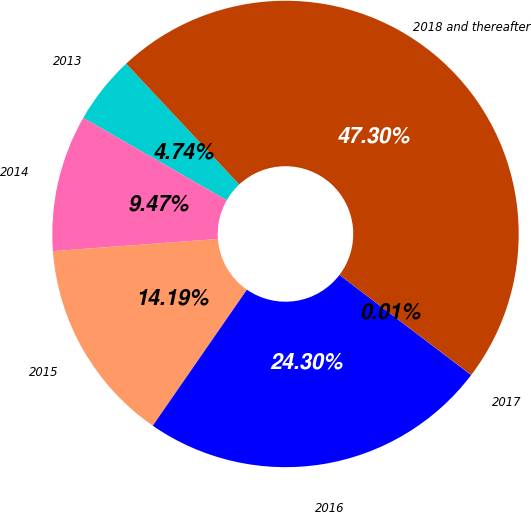<chart> <loc_0><loc_0><loc_500><loc_500><pie_chart><fcel>2013<fcel>2014<fcel>2015<fcel>2016<fcel>2017<fcel>2018 and thereafter<nl><fcel>4.74%<fcel>9.47%<fcel>14.19%<fcel>24.3%<fcel>0.01%<fcel>47.3%<nl></chart> 